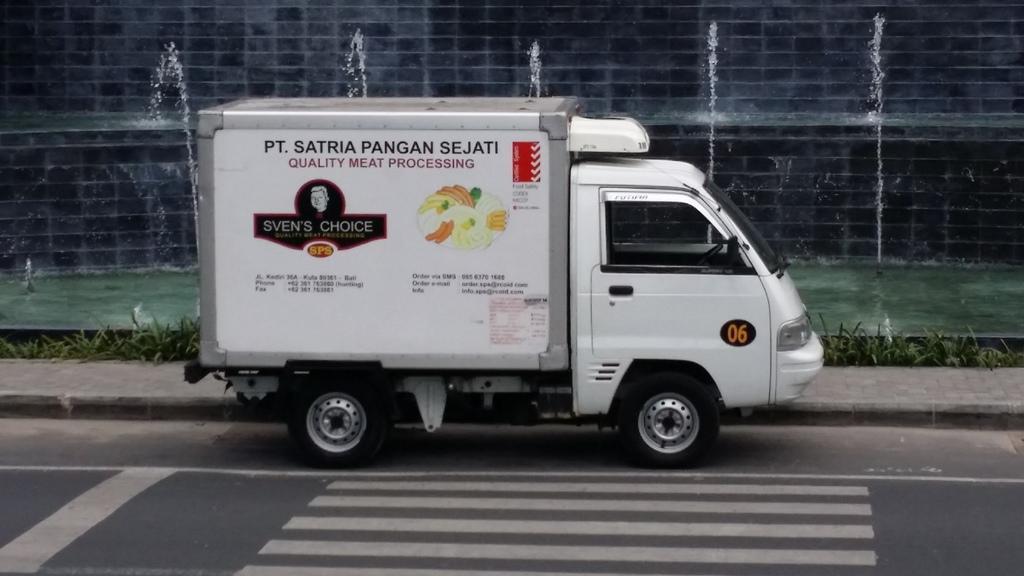Describe this image in one or two sentences. In this image we can see a vehicle on the road and to the side there is a sidewalk. We can see some plants and in the background, there is a wall and a water fountain. 